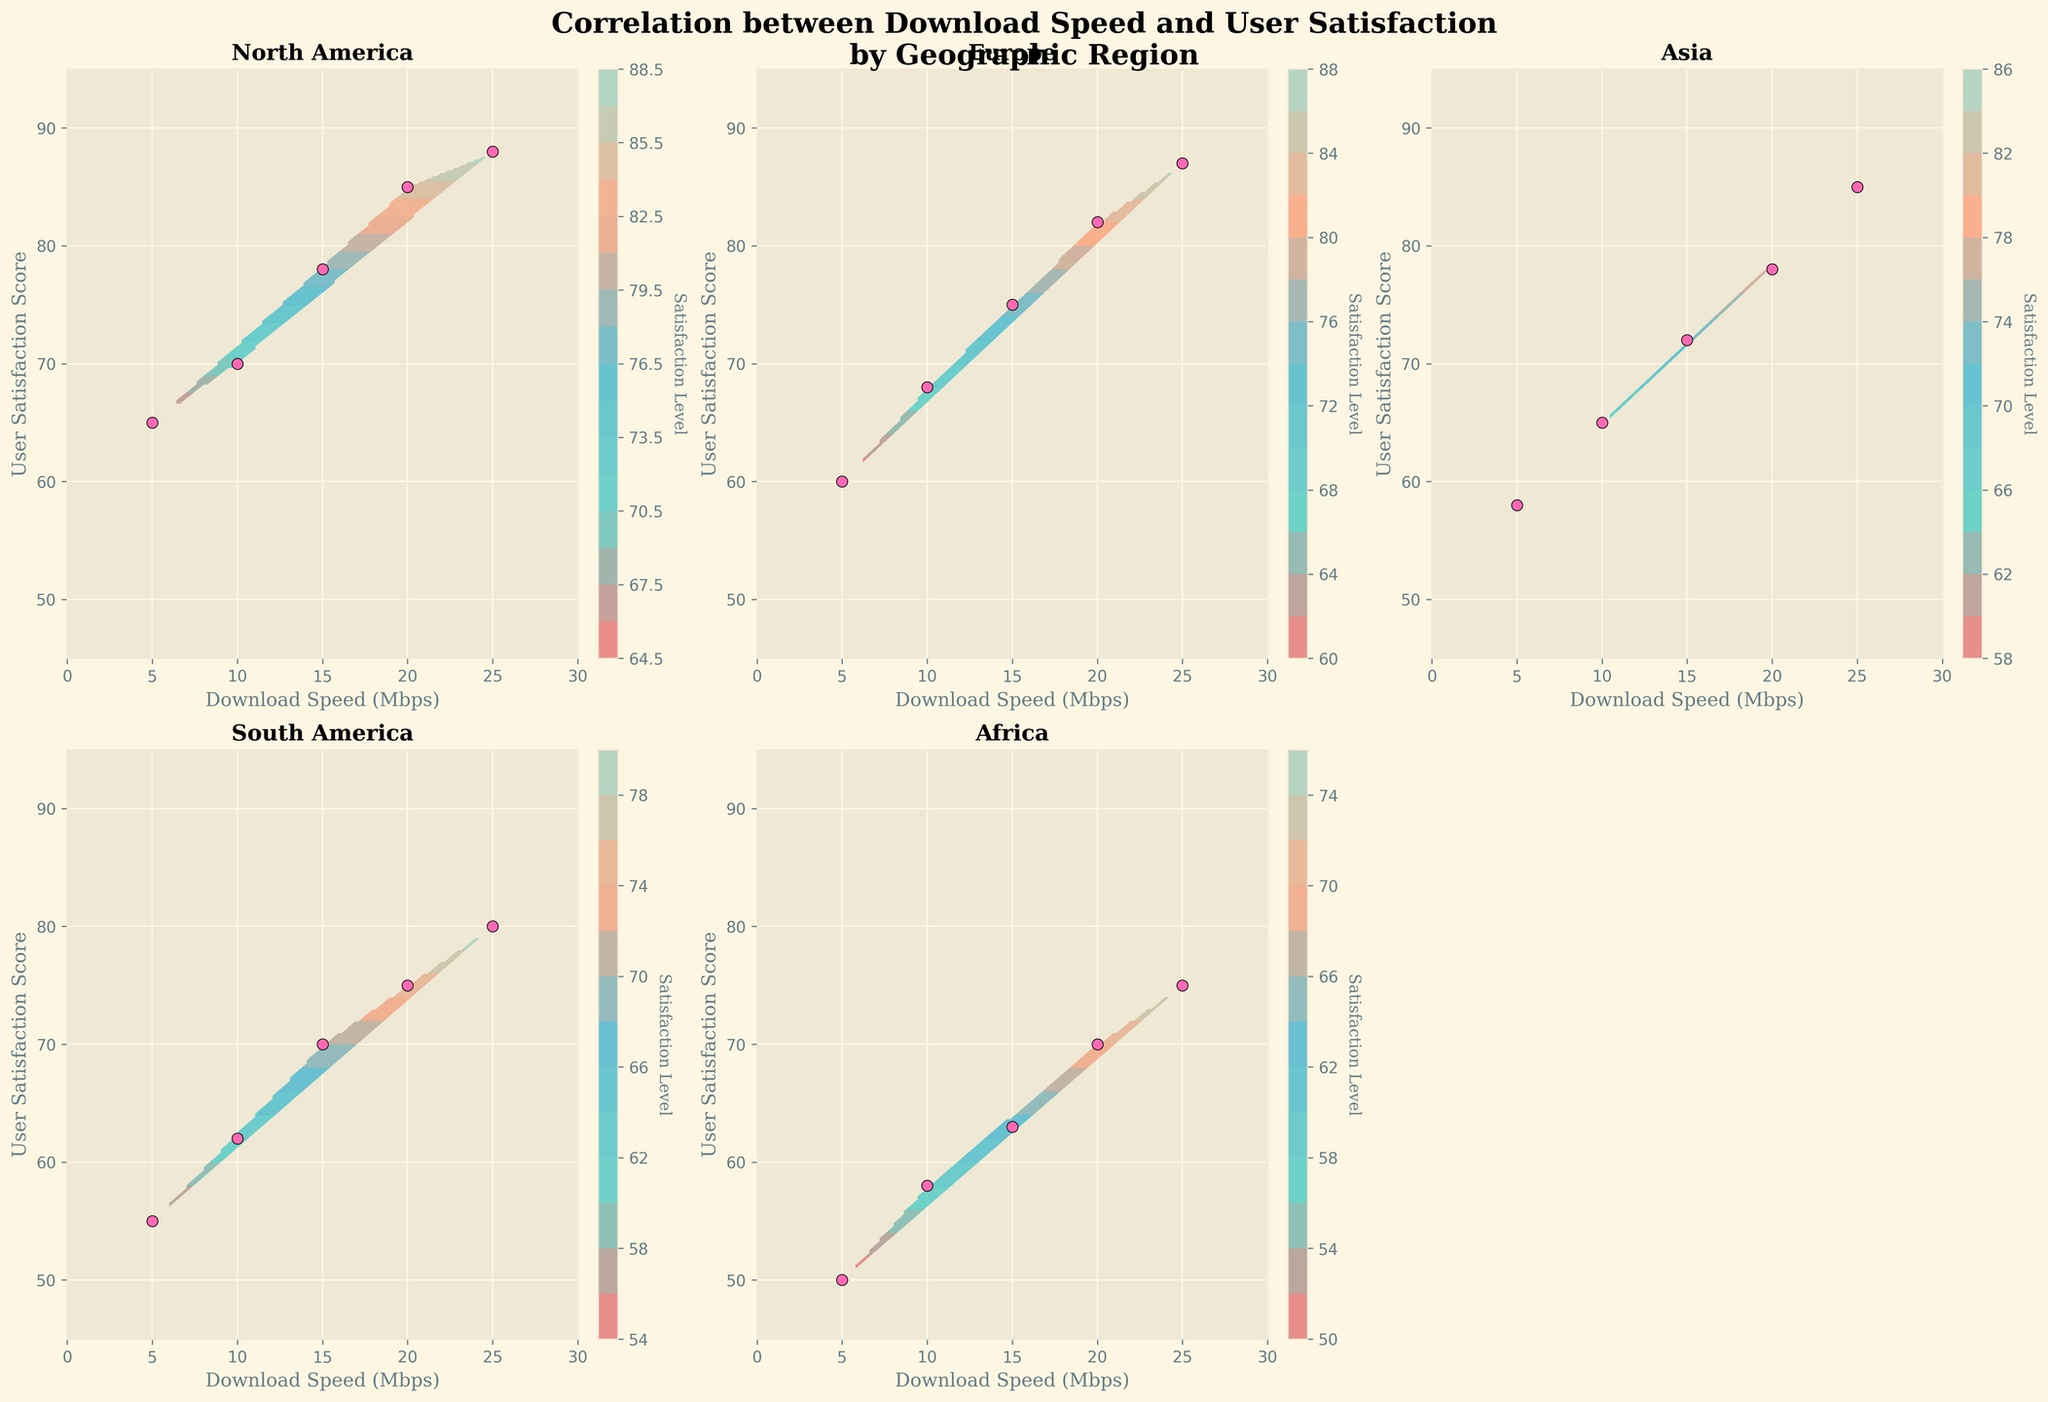What is the title of the figure? The title of the figure is located at the top and provides an overview of what the figure represents. It reads "Correlation between Download Speed and User Satisfaction\nby Geographic Region".
Answer: Correlation between Download Speed and User Satisfaction by Geographic Region How many regions are shown in the figure? The figure consists of several individual subplots, each representing a different region. By counting the number of subplots with titles indicating geographic regions, one can determine the total number of regions displayed. There are five regions shown: North America, Europe, Asia, South America, and Africa.
Answer: 5 Which region has the highest user satisfaction at the maximum download speed? To answer this, we need to look at the upper right side of each subplot where the maximum download speed (25 Mbps) is mapped against user satisfaction. The highest satisfaction score is found in the North America subplot with a user satisfaction score of 88.
Answer: North America Is there a region where user satisfaction scores start lower but also have a significant increase as download speed increases? By observing the lower end of the satisfaction scores for each region and tracking how they increase alongside download speed, we can analyze South America. It starts with a lower satisfaction score (55) at the lowest download speed and sees a substantial increase, reaching 80 at the highest speed.
Answer: South America What trend do most regions show about the relationship between download speed and user satisfaction? By examining the contour density and the scatter plots in each subplot, a general trend can be seen where user satisfaction increases as download speed increases. This trend appears consistently across all regions.
Answer: Increasing satisfaction with increasing download speed Which two regions have the closest user satisfaction scores at the maximum download speed? To determine this, compare the user satisfaction scores at the 25 Mbps download speed across subplots. Europe and Asia have very close satisfaction scores (87 and 85, respectively).
Answer: Europe and Asia At a download speed of 5 Mbps, which region has the lowest user satisfaction score? Reviewing the subplots at the intersection where download speed is 5 Mbps and noting the corresponding user satisfaction scores, Africa has the lowest satisfaction score at this download speed with a score of 50.
Answer: Africa What's the average user satisfaction score for Europe at different download speeds? To find the average, sum the satisfaction scores for Europe (60, 68, 75, 82, 87) and then divide by the number of points (5). (60 + 68 + 75 + 82 + 87) / 5 = 74.4
Answer: 74.4 Does any region have the exact same user satisfaction score for more than one download speed? Examining each subplot for repeated user satisfaction scores at different download speeds shows that none of the regions have the exact same score multiple times.
Answer: No 